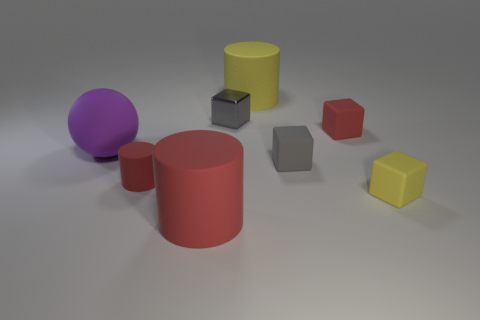What is the size of the purple sphere that is behind the rubber cube to the left of the red matte block?
Provide a succinct answer. Large. How many objects are either large blue cubes or metallic things?
Offer a very short reply. 1. Is the shape of the tiny gray rubber object the same as the purple rubber object?
Make the answer very short. No. Are there any large purple balls made of the same material as the purple thing?
Keep it short and to the point. No. Is there a red rubber cylinder that is to the left of the red object behind the large purple rubber object?
Your response must be concise. Yes. Is the size of the red rubber cylinder in front of the yellow matte block the same as the gray metal thing?
Ensure brevity in your answer.  No. What size is the red cube?
Offer a terse response. Small. Is there a big matte ball of the same color as the tiny cylinder?
Your answer should be very brief. No. How many big things are either purple spheres or yellow things?
Your answer should be compact. 2. What size is the red matte thing that is both behind the big red matte cylinder and in front of the purple object?
Offer a very short reply. Small. 